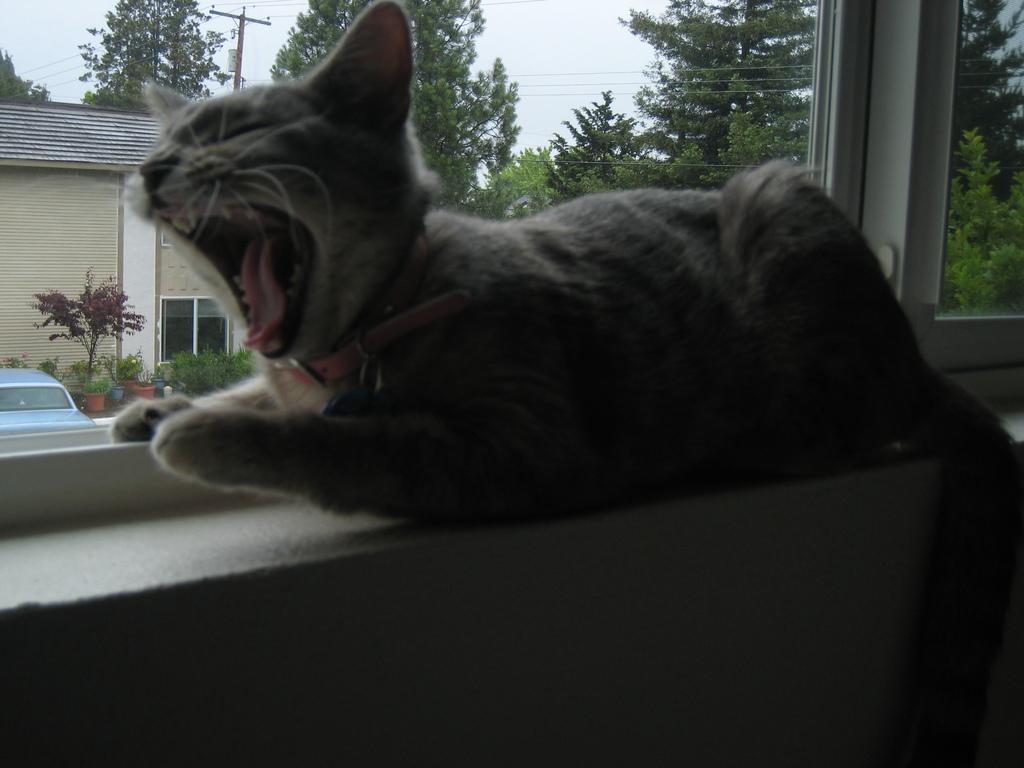What animal is on the wall in the image? There is a cat on the wall in the image. What can be seen through the window in the image? Trees, a pole, plants, a house, and a car are visible from the window in the image. What is visible in the background of the image? The sky is visible in the background of the image. What type of learning is the cat participating in while on the wall? The cat is not participating in any learning activity in the image; it is simply on the wall. 